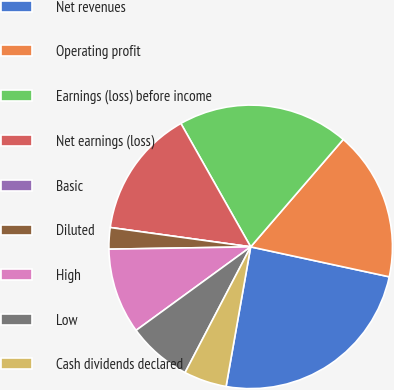Convert chart to OTSL. <chart><loc_0><loc_0><loc_500><loc_500><pie_chart><fcel>Net revenues<fcel>Operating profit<fcel>Earnings (loss) before income<fcel>Net earnings (loss)<fcel>Basic<fcel>Diluted<fcel>High<fcel>Low<fcel>Cash dividends declared<nl><fcel>24.39%<fcel>17.07%<fcel>19.51%<fcel>14.63%<fcel>0.0%<fcel>2.44%<fcel>9.76%<fcel>7.32%<fcel>4.88%<nl></chart> 